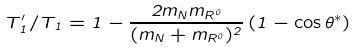<formula> <loc_0><loc_0><loc_500><loc_500>T ^ { \prime } _ { 1 } / T _ { 1 } = 1 - \frac { 2 m _ { N } m _ { R ^ { 0 } } } { ( m _ { N } + m _ { R ^ { 0 } } ) ^ { 2 } } \, ( 1 - \cos \theta ^ { * } )</formula> 